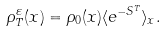Convert formula to latex. <formula><loc_0><loc_0><loc_500><loc_500>\rho _ { T } ^ { \varepsilon } ( x ) = \rho _ { 0 } ( x ) \langle e ^ { - S ^ { T } } \rangle _ { x } .</formula> 